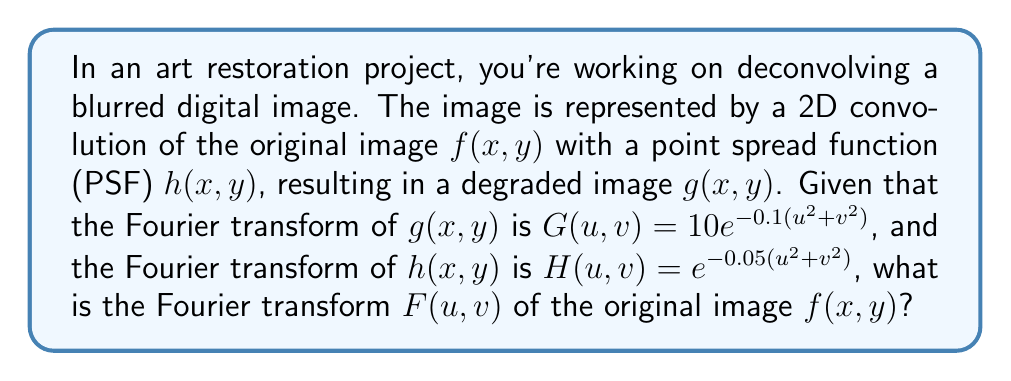Can you solve this math problem? Let's approach this step-by-step:

1) In the frequency domain, the convolution of two functions becomes a multiplication:

   $G(u,v) = H(u,v) \cdot F(u,v)$

2) We are given:
   $G(u,v) = 10e^{-0.1(u^2+v^2)}$
   $H(u,v) = e^{-0.05(u^2+v^2)}$

3) To find $F(u,v)$, we need to divide $G(u,v)$ by $H(u,v)$:

   $F(u,v) = \frac{G(u,v)}{H(u,v)}$

4) Let's substitute the given functions:

   $F(u,v) = \frac{10e^{-0.1(u^2+v^2)}}{e^{-0.05(u^2+v^2)}}$

5) Simplify the exponentials:

   $F(u,v) = 10 \cdot \frac{e^{-0.1(u^2+v^2)}}{e^{-0.05(u^2+v^2)}}$
   
   $F(u,v) = 10 \cdot e^{-0.1(u^2+v^2) + 0.05(u^2+v^2)}$
   
   $F(u,v) = 10 \cdot e^{-0.05(u^2+v^2)}$

6) Therefore, the Fourier transform of the original image is:

   $F(u,v) = 10e^{-0.05(u^2+v^2)}$

This result represents the frequency domain representation of the original, unblurred image. To obtain the spatial domain image $f(x,y)$, you would need to apply an inverse Fourier transform to $F(u,v)$.
Answer: $F(u,v) = 10e^{-0.05(u^2+v^2)}$ 